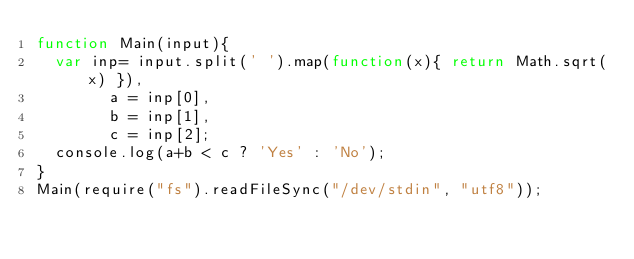Convert code to text. <code><loc_0><loc_0><loc_500><loc_500><_JavaScript_>function Main(input){
	var inp= input.split(' ').map(function(x){ return Math.sqrt(x) }),
        a = inp[0],
        b = inp[1],
        c = inp[2];
	console.log(a+b < c ? 'Yes' : 'No');
}
Main(require("fs").readFileSync("/dev/stdin", "utf8"));</code> 